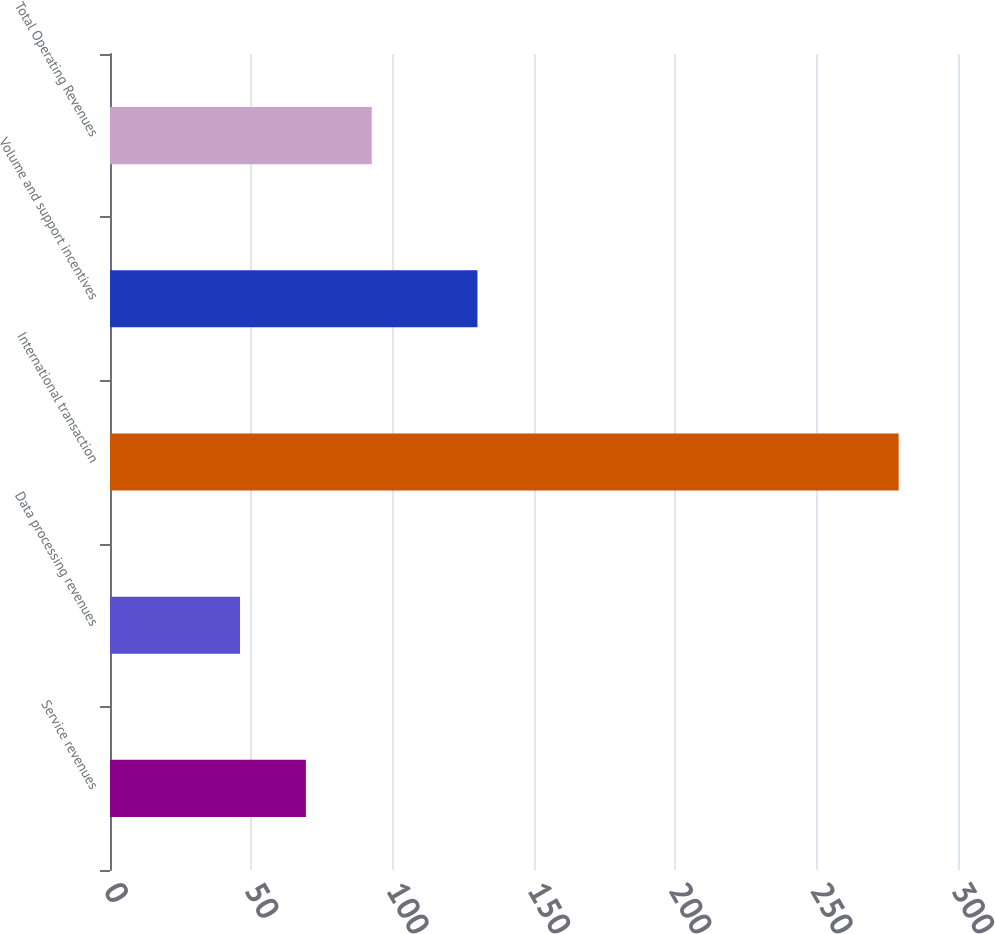Convert chart. <chart><loc_0><loc_0><loc_500><loc_500><bar_chart><fcel>Service revenues<fcel>Data processing revenues<fcel>International transaction<fcel>Volume and support incentives<fcel>Total Operating Revenues<nl><fcel>69.3<fcel>46<fcel>279<fcel>130<fcel>92.6<nl></chart> 